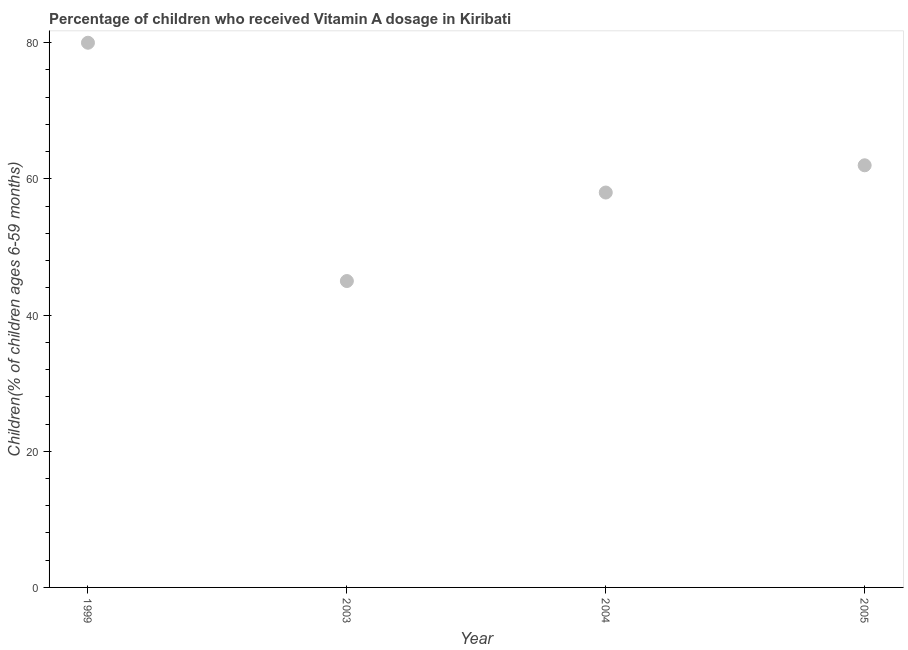What is the vitamin a supplementation coverage rate in 2004?
Your response must be concise. 58. Across all years, what is the maximum vitamin a supplementation coverage rate?
Offer a very short reply. 80. Across all years, what is the minimum vitamin a supplementation coverage rate?
Give a very brief answer. 45. In which year was the vitamin a supplementation coverage rate maximum?
Provide a succinct answer. 1999. What is the sum of the vitamin a supplementation coverage rate?
Offer a very short reply. 245. What is the difference between the vitamin a supplementation coverage rate in 1999 and 2004?
Make the answer very short. 22. What is the average vitamin a supplementation coverage rate per year?
Your response must be concise. 61.25. What is the median vitamin a supplementation coverage rate?
Provide a succinct answer. 60. In how many years, is the vitamin a supplementation coverage rate greater than 20 %?
Keep it short and to the point. 4. What is the ratio of the vitamin a supplementation coverage rate in 1999 to that in 2004?
Keep it short and to the point. 1.38. Is the difference between the vitamin a supplementation coverage rate in 2004 and 2005 greater than the difference between any two years?
Offer a very short reply. No. Is the sum of the vitamin a supplementation coverage rate in 1999 and 2005 greater than the maximum vitamin a supplementation coverage rate across all years?
Give a very brief answer. Yes. What is the difference between the highest and the lowest vitamin a supplementation coverage rate?
Offer a very short reply. 35. Does the vitamin a supplementation coverage rate monotonically increase over the years?
Your response must be concise. No. How many years are there in the graph?
Give a very brief answer. 4. Are the values on the major ticks of Y-axis written in scientific E-notation?
Your answer should be compact. No. Does the graph contain any zero values?
Keep it short and to the point. No. What is the title of the graph?
Provide a short and direct response. Percentage of children who received Vitamin A dosage in Kiribati. What is the label or title of the Y-axis?
Provide a short and direct response. Children(% of children ages 6-59 months). What is the Children(% of children ages 6-59 months) in 1999?
Your answer should be very brief. 80. What is the Children(% of children ages 6-59 months) in 2003?
Your answer should be very brief. 45. What is the Children(% of children ages 6-59 months) in 2004?
Give a very brief answer. 58. What is the difference between the Children(% of children ages 6-59 months) in 1999 and 2004?
Provide a succinct answer. 22. What is the difference between the Children(% of children ages 6-59 months) in 2003 and 2004?
Give a very brief answer. -13. What is the difference between the Children(% of children ages 6-59 months) in 2003 and 2005?
Make the answer very short. -17. What is the difference between the Children(% of children ages 6-59 months) in 2004 and 2005?
Provide a short and direct response. -4. What is the ratio of the Children(% of children ages 6-59 months) in 1999 to that in 2003?
Offer a terse response. 1.78. What is the ratio of the Children(% of children ages 6-59 months) in 1999 to that in 2004?
Your response must be concise. 1.38. What is the ratio of the Children(% of children ages 6-59 months) in 1999 to that in 2005?
Your answer should be very brief. 1.29. What is the ratio of the Children(% of children ages 6-59 months) in 2003 to that in 2004?
Your response must be concise. 0.78. What is the ratio of the Children(% of children ages 6-59 months) in 2003 to that in 2005?
Your response must be concise. 0.73. What is the ratio of the Children(% of children ages 6-59 months) in 2004 to that in 2005?
Your answer should be compact. 0.94. 